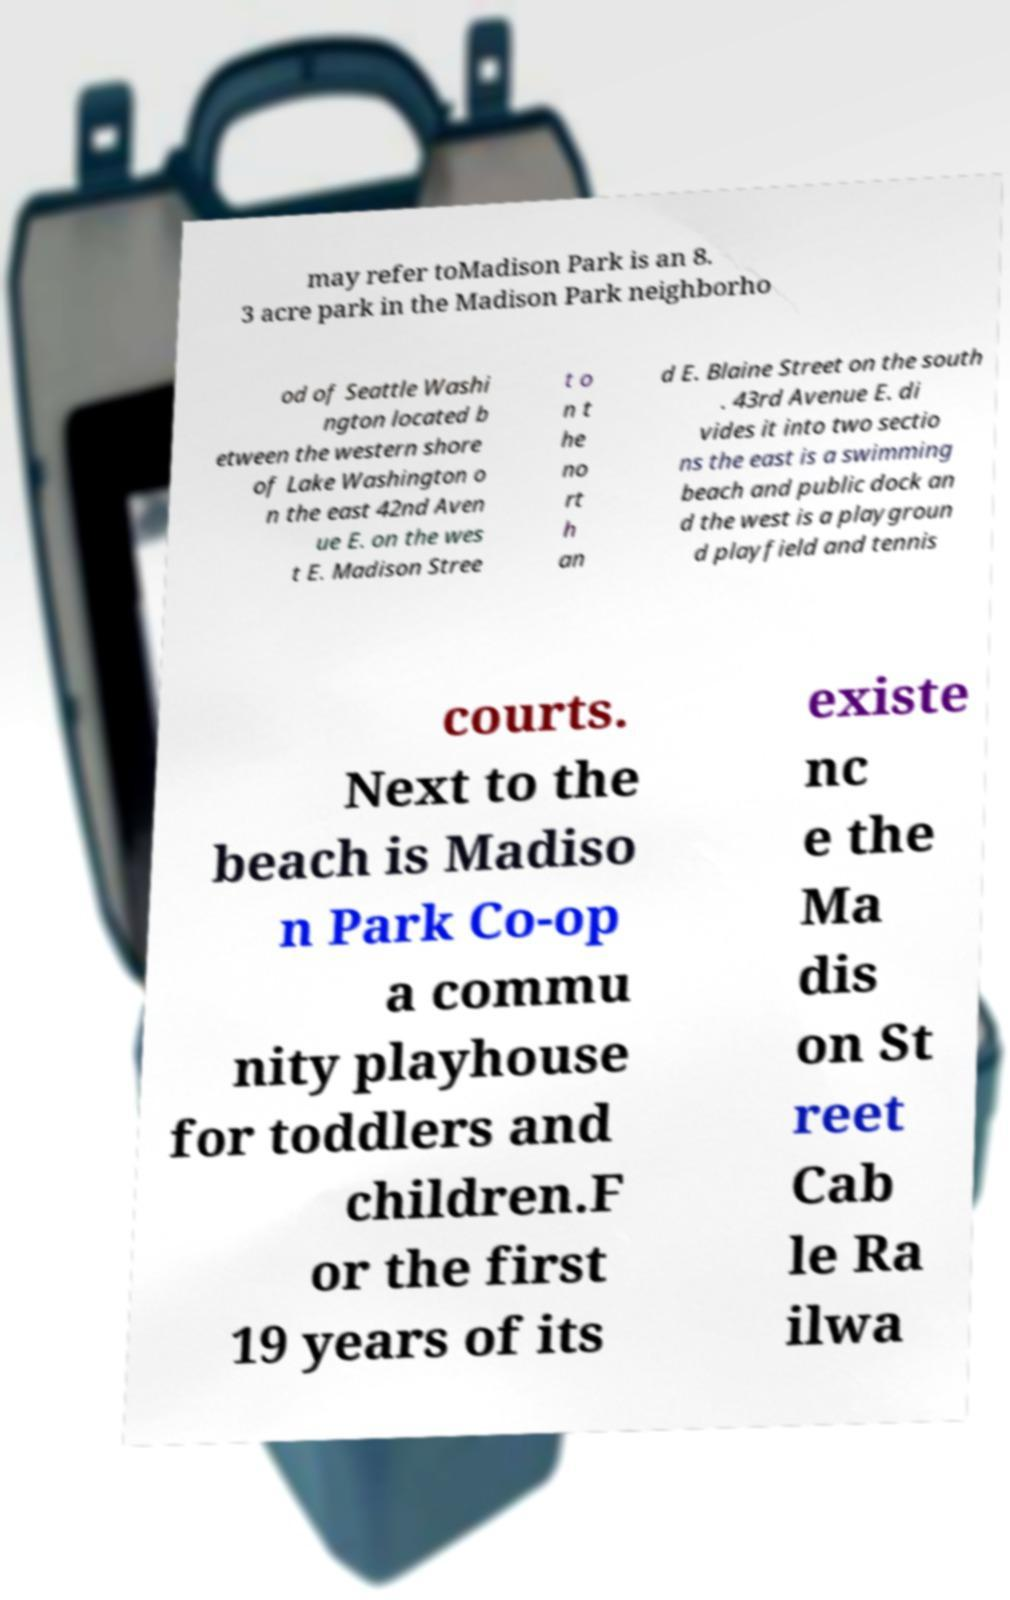Can you accurately transcribe the text from the provided image for me? may refer toMadison Park is an 8. 3 acre park in the Madison Park neighborho od of Seattle Washi ngton located b etween the western shore of Lake Washington o n the east 42nd Aven ue E. on the wes t E. Madison Stree t o n t he no rt h an d E. Blaine Street on the south . 43rd Avenue E. di vides it into two sectio ns the east is a swimming beach and public dock an d the west is a playgroun d playfield and tennis courts. Next to the beach is Madiso n Park Co-op a commu nity playhouse for toddlers and children.F or the first 19 years of its existe nc e the Ma dis on St reet Cab le Ra ilwa 